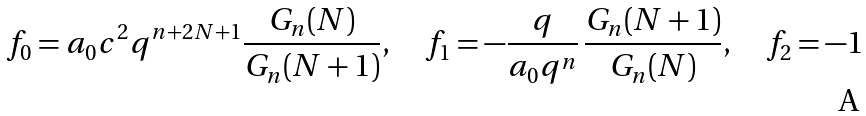Convert formula to latex. <formula><loc_0><loc_0><loc_500><loc_500>f _ { 0 } = a _ { 0 } c ^ { 2 } q ^ { n + 2 N + 1 } \frac { G _ { n } ( N ) } { G _ { n } ( N + 1 ) } , \quad f _ { 1 } = - \frac { q } { a _ { 0 } q ^ { n } } \, \frac { G _ { n } ( N + 1 ) } { G _ { n } ( N ) } , \quad f _ { 2 } = - 1</formula> 